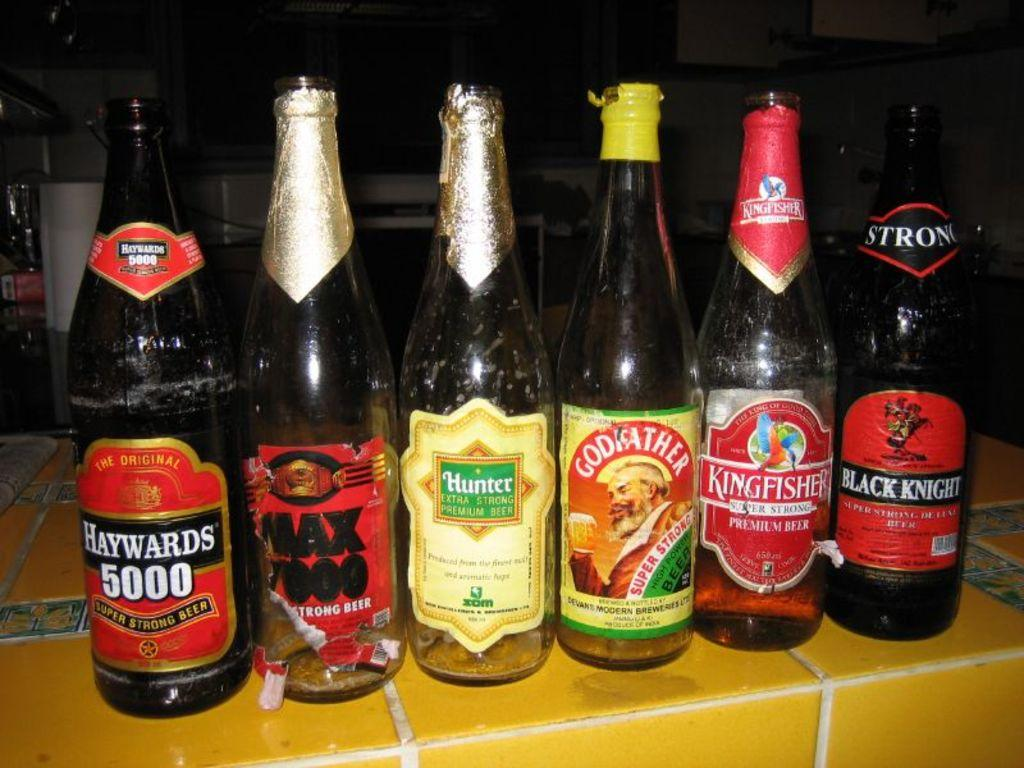<image>
Present a compact description of the photo's key features. Six bottles of alcohol with Black Knight on the far right. 